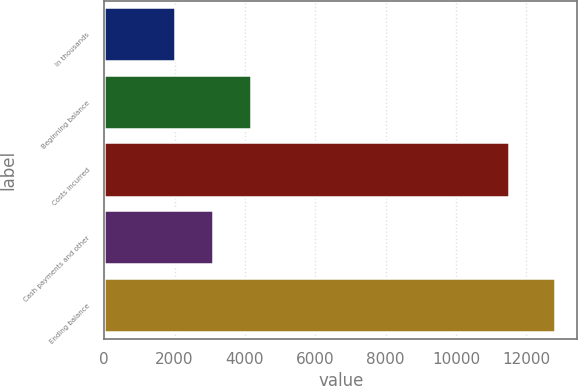Convert chart. <chart><loc_0><loc_0><loc_500><loc_500><bar_chart><fcel>In thousands<fcel>Beginning balance<fcel>Costs incurred<fcel>Cash payments and other<fcel>Ending balance<nl><fcel>2011<fcel>4169.8<fcel>11500<fcel>3090.4<fcel>12805<nl></chart> 